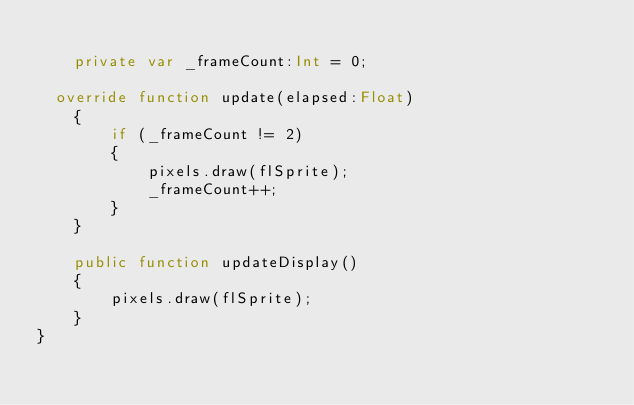<code> <loc_0><loc_0><loc_500><loc_500><_Haxe_>
    private var _frameCount:Int = 0;

	override function update(elapsed:Float)
    {
        if (_frameCount != 2)
        {
            pixels.draw(flSprite);
            _frameCount++;
        }
    }

    public function updateDisplay()
    {
        pixels.draw(flSprite);
    }
}</code> 